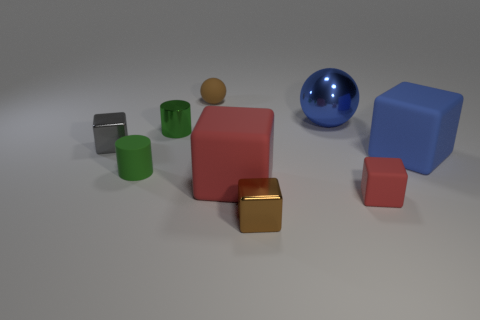Subtract all large blue blocks. How many blocks are left? 4 Add 1 large matte things. How many objects exist? 10 Subtract all brown cubes. How many cubes are left? 4 Subtract 1 green cylinders. How many objects are left? 8 Subtract all cylinders. How many objects are left? 7 Subtract 2 balls. How many balls are left? 0 Subtract all cyan cylinders. Subtract all blue balls. How many cylinders are left? 2 Subtract all gray balls. How many yellow cubes are left? 0 Subtract all tiny gray shiny objects. Subtract all green metal cylinders. How many objects are left? 7 Add 1 red matte things. How many red matte things are left? 3 